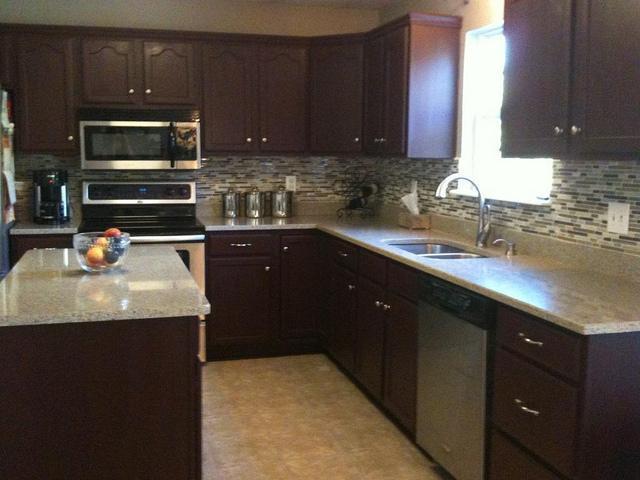The glare from the sun may interfere with a persons ability to do what while cooking?
Make your selection from the four choices given to correctly answer the question.
Options: Touch, think, smell, see. See. 